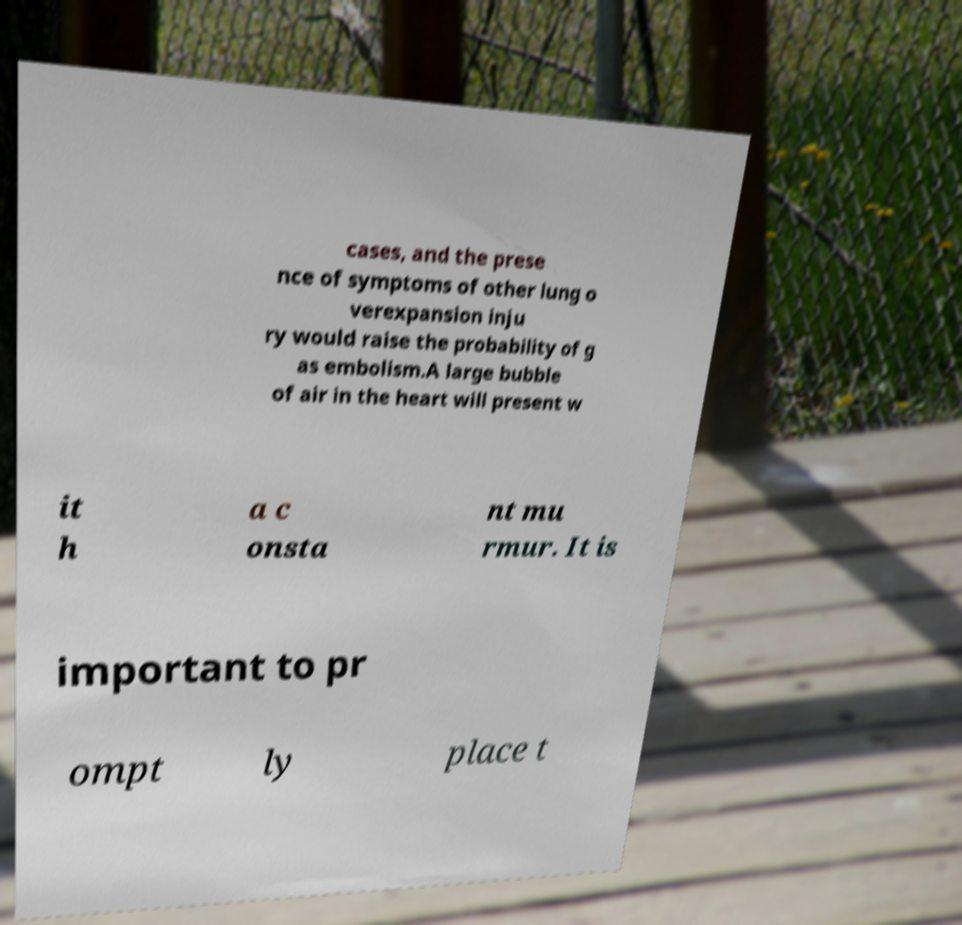Please identify and transcribe the text found in this image. cases, and the prese nce of symptoms of other lung o verexpansion inju ry would raise the probability of g as embolism.A large bubble of air in the heart will present w it h a c onsta nt mu rmur. It is important to pr ompt ly place t 